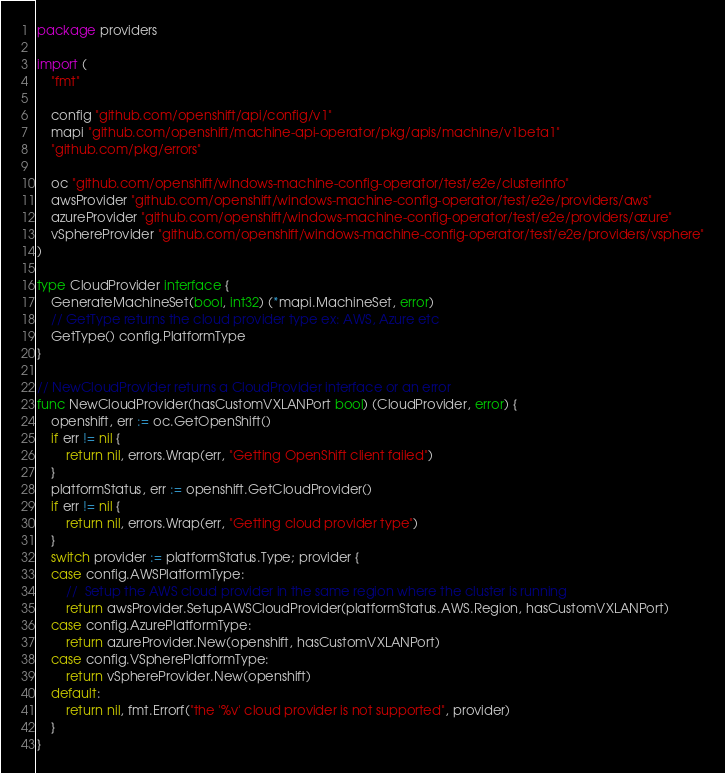<code> <loc_0><loc_0><loc_500><loc_500><_Go_>package providers

import (
	"fmt"

	config "github.com/openshift/api/config/v1"
	mapi "github.com/openshift/machine-api-operator/pkg/apis/machine/v1beta1"
	"github.com/pkg/errors"

	oc "github.com/openshift/windows-machine-config-operator/test/e2e/clusterinfo"
	awsProvider "github.com/openshift/windows-machine-config-operator/test/e2e/providers/aws"
	azureProvider "github.com/openshift/windows-machine-config-operator/test/e2e/providers/azure"
	vSphereProvider "github.com/openshift/windows-machine-config-operator/test/e2e/providers/vsphere"
)

type CloudProvider interface {
	GenerateMachineSet(bool, int32) (*mapi.MachineSet, error)
	// GetType returns the cloud provider type ex: AWS, Azure etc
	GetType() config.PlatformType
}

// NewCloudProvider returns a CloudProvider interface or an error
func NewCloudProvider(hasCustomVXLANPort bool) (CloudProvider, error) {
	openshift, err := oc.GetOpenShift()
	if err != nil {
		return nil, errors.Wrap(err, "Getting OpenShift client failed")
	}
	platformStatus, err := openshift.GetCloudProvider()
	if err != nil {
		return nil, errors.Wrap(err, "Getting cloud provider type")
	}
	switch provider := platformStatus.Type; provider {
	case config.AWSPlatformType:
		// 	Setup the AWS cloud provider in the same region where the cluster is running
		return awsProvider.SetupAWSCloudProvider(platformStatus.AWS.Region, hasCustomVXLANPort)
	case config.AzurePlatformType:
		return azureProvider.New(openshift, hasCustomVXLANPort)
	case config.VSpherePlatformType:
		return vSphereProvider.New(openshift)
	default:
		return nil, fmt.Errorf("the '%v' cloud provider is not supported", provider)
	}
}
</code> 